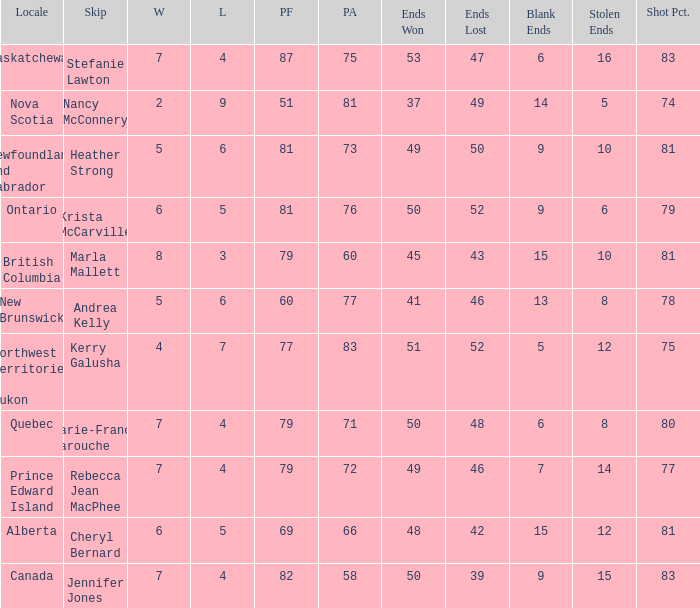Where was the shot pct 78? New Brunswick. 